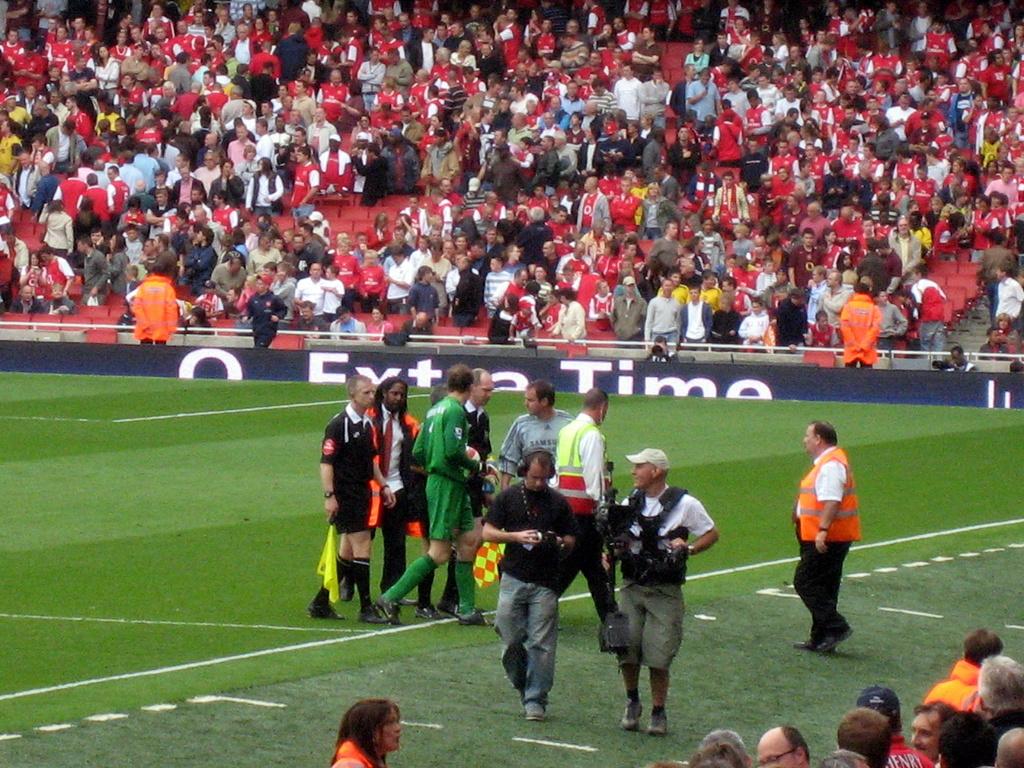What kind of time is on the adboard?
Provide a short and direct response. Extra time. 